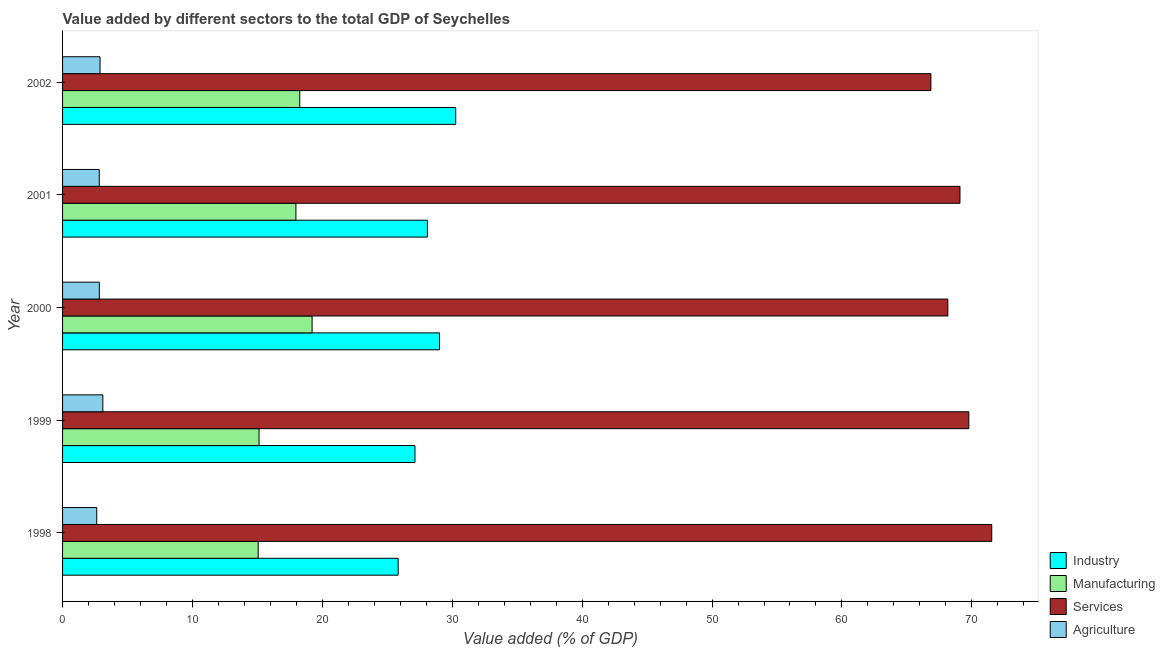How many groups of bars are there?
Your answer should be compact. 5. Are the number of bars per tick equal to the number of legend labels?
Your answer should be very brief. Yes. How many bars are there on the 2nd tick from the top?
Your response must be concise. 4. In how many cases, is the number of bars for a given year not equal to the number of legend labels?
Your answer should be very brief. 0. What is the value added by manufacturing sector in 2002?
Your answer should be very brief. 18.26. Across all years, what is the maximum value added by agricultural sector?
Provide a succinct answer. 3.1. Across all years, what is the minimum value added by agricultural sector?
Your response must be concise. 2.63. In which year was the value added by services sector maximum?
Keep it short and to the point. 1998. What is the total value added by manufacturing sector in the graph?
Make the answer very short. 85.62. What is the difference between the value added by manufacturing sector in 2000 and that in 2002?
Provide a short and direct response. 0.95. What is the difference between the value added by agricultural sector in 2001 and the value added by manufacturing sector in 1998?
Give a very brief answer. -12.23. What is the average value added by services sector per year?
Give a very brief answer. 69.08. In the year 2001, what is the difference between the value added by services sector and value added by agricultural sector?
Provide a short and direct response. 66.26. Is the value added by agricultural sector in 2000 less than that in 2002?
Keep it short and to the point. Yes. Is the difference between the value added by services sector in 1999 and 2000 greater than the difference between the value added by agricultural sector in 1999 and 2000?
Give a very brief answer. Yes. What is the difference between the highest and the second highest value added by services sector?
Provide a succinct answer. 1.76. What is the difference between the highest and the lowest value added by industrial sector?
Your answer should be very brief. 4.43. In how many years, is the value added by agricultural sector greater than the average value added by agricultural sector taken over all years?
Offer a very short reply. 2. Is the sum of the value added by industrial sector in 1999 and 2000 greater than the maximum value added by agricultural sector across all years?
Your answer should be very brief. Yes. Is it the case that in every year, the sum of the value added by services sector and value added by manufacturing sector is greater than the sum of value added by agricultural sector and value added by industrial sector?
Give a very brief answer. Yes. What does the 1st bar from the top in 1999 represents?
Provide a succinct answer. Agriculture. What does the 4th bar from the bottom in 1999 represents?
Provide a short and direct response. Agriculture. Is it the case that in every year, the sum of the value added by industrial sector and value added by manufacturing sector is greater than the value added by services sector?
Offer a terse response. No. How many bars are there?
Your response must be concise. 20. Are all the bars in the graph horizontal?
Give a very brief answer. Yes. Are the values on the major ticks of X-axis written in scientific E-notation?
Keep it short and to the point. No. Does the graph contain grids?
Your response must be concise. No. Where does the legend appear in the graph?
Make the answer very short. Bottom right. How are the legend labels stacked?
Your response must be concise. Vertical. What is the title of the graph?
Offer a terse response. Value added by different sectors to the total GDP of Seychelles. What is the label or title of the X-axis?
Offer a very short reply. Value added (% of GDP). What is the label or title of the Y-axis?
Keep it short and to the point. Year. What is the Value added (% of GDP) of Industry in 1998?
Give a very brief answer. 25.84. What is the Value added (% of GDP) in Manufacturing in 1998?
Your answer should be compact. 15.06. What is the Value added (% of GDP) in Services in 1998?
Make the answer very short. 71.53. What is the Value added (% of GDP) in Agriculture in 1998?
Provide a succinct answer. 2.63. What is the Value added (% of GDP) in Industry in 1999?
Your response must be concise. 27.13. What is the Value added (% of GDP) in Manufacturing in 1999?
Your answer should be compact. 15.12. What is the Value added (% of GDP) of Services in 1999?
Offer a terse response. 69.77. What is the Value added (% of GDP) of Agriculture in 1999?
Provide a short and direct response. 3.1. What is the Value added (% of GDP) in Industry in 2000?
Offer a terse response. 29.02. What is the Value added (% of GDP) of Manufacturing in 2000?
Ensure brevity in your answer.  19.21. What is the Value added (% of GDP) in Services in 2000?
Give a very brief answer. 68.15. What is the Value added (% of GDP) in Agriculture in 2000?
Give a very brief answer. 2.83. What is the Value added (% of GDP) of Industry in 2001?
Give a very brief answer. 28.09. What is the Value added (% of GDP) in Manufacturing in 2001?
Give a very brief answer. 17.96. What is the Value added (% of GDP) of Services in 2001?
Provide a short and direct response. 69.09. What is the Value added (% of GDP) of Agriculture in 2001?
Provide a succinct answer. 2.83. What is the Value added (% of GDP) in Industry in 2002?
Make the answer very short. 30.27. What is the Value added (% of GDP) of Manufacturing in 2002?
Give a very brief answer. 18.26. What is the Value added (% of GDP) of Services in 2002?
Ensure brevity in your answer.  66.85. What is the Value added (% of GDP) in Agriculture in 2002?
Ensure brevity in your answer.  2.89. Across all years, what is the maximum Value added (% of GDP) in Industry?
Provide a succinct answer. 30.27. Across all years, what is the maximum Value added (% of GDP) of Manufacturing?
Provide a succinct answer. 19.21. Across all years, what is the maximum Value added (% of GDP) of Services?
Offer a very short reply. 71.53. Across all years, what is the maximum Value added (% of GDP) in Agriculture?
Give a very brief answer. 3.1. Across all years, what is the minimum Value added (% of GDP) of Industry?
Offer a terse response. 25.84. Across all years, what is the minimum Value added (% of GDP) in Manufacturing?
Keep it short and to the point. 15.06. Across all years, what is the minimum Value added (% of GDP) in Services?
Ensure brevity in your answer.  66.85. Across all years, what is the minimum Value added (% of GDP) of Agriculture?
Offer a very short reply. 2.63. What is the total Value added (% of GDP) of Industry in the graph?
Your answer should be compact. 140.34. What is the total Value added (% of GDP) in Manufacturing in the graph?
Provide a succinct answer. 85.62. What is the total Value added (% of GDP) of Services in the graph?
Provide a short and direct response. 345.39. What is the total Value added (% of GDP) of Agriculture in the graph?
Provide a short and direct response. 14.27. What is the difference between the Value added (% of GDP) in Industry in 1998 and that in 1999?
Offer a terse response. -1.29. What is the difference between the Value added (% of GDP) in Manufacturing in 1998 and that in 1999?
Give a very brief answer. -0.07. What is the difference between the Value added (% of GDP) of Services in 1998 and that in 1999?
Provide a succinct answer. 1.77. What is the difference between the Value added (% of GDP) of Agriculture in 1998 and that in 1999?
Provide a succinct answer. -0.47. What is the difference between the Value added (% of GDP) of Industry in 1998 and that in 2000?
Keep it short and to the point. -3.18. What is the difference between the Value added (% of GDP) of Manufacturing in 1998 and that in 2000?
Provide a short and direct response. -4.15. What is the difference between the Value added (% of GDP) in Services in 1998 and that in 2000?
Give a very brief answer. 3.38. What is the difference between the Value added (% of GDP) in Agriculture in 1998 and that in 2000?
Provide a succinct answer. -0.2. What is the difference between the Value added (% of GDP) in Industry in 1998 and that in 2001?
Ensure brevity in your answer.  -2.25. What is the difference between the Value added (% of GDP) in Manufacturing in 1998 and that in 2001?
Make the answer very short. -2.91. What is the difference between the Value added (% of GDP) of Services in 1998 and that in 2001?
Keep it short and to the point. 2.45. What is the difference between the Value added (% of GDP) in Agriculture in 1998 and that in 2001?
Make the answer very short. -0.2. What is the difference between the Value added (% of GDP) in Industry in 1998 and that in 2002?
Provide a short and direct response. -4.43. What is the difference between the Value added (% of GDP) in Manufacturing in 1998 and that in 2002?
Ensure brevity in your answer.  -3.2. What is the difference between the Value added (% of GDP) of Services in 1998 and that in 2002?
Offer a very short reply. 4.69. What is the difference between the Value added (% of GDP) in Agriculture in 1998 and that in 2002?
Provide a succinct answer. -0.26. What is the difference between the Value added (% of GDP) in Industry in 1999 and that in 2000?
Give a very brief answer. -1.89. What is the difference between the Value added (% of GDP) in Manufacturing in 1999 and that in 2000?
Your answer should be compact. -4.08. What is the difference between the Value added (% of GDP) in Services in 1999 and that in 2000?
Offer a very short reply. 1.62. What is the difference between the Value added (% of GDP) of Agriculture in 1999 and that in 2000?
Give a very brief answer. 0.27. What is the difference between the Value added (% of GDP) of Industry in 1999 and that in 2001?
Make the answer very short. -0.95. What is the difference between the Value added (% of GDP) in Manufacturing in 1999 and that in 2001?
Your answer should be compact. -2.84. What is the difference between the Value added (% of GDP) in Services in 1999 and that in 2001?
Provide a succinct answer. 0.68. What is the difference between the Value added (% of GDP) of Agriculture in 1999 and that in 2001?
Offer a terse response. 0.27. What is the difference between the Value added (% of GDP) of Industry in 1999 and that in 2002?
Offer a very short reply. -3.14. What is the difference between the Value added (% of GDP) of Manufacturing in 1999 and that in 2002?
Your response must be concise. -3.14. What is the difference between the Value added (% of GDP) of Services in 1999 and that in 2002?
Give a very brief answer. 2.92. What is the difference between the Value added (% of GDP) in Agriculture in 1999 and that in 2002?
Provide a short and direct response. 0.22. What is the difference between the Value added (% of GDP) in Industry in 2000 and that in 2001?
Ensure brevity in your answer.  0.93. What is the difference between the Value added (% of GDP) in Manufacturing in 2000 and that in 2001?
Offer a very short reply. 1.25. What is the difference between the Value added (% of GDP) of Services in 2000 and that in 2001?
Give a very brief answer. -0.94. What is the difference between the Value added (% of GDP) of Agriculture in 2000 and that in 2001?
Give a very brief answer. 0. What is the difference between the Value added (% of GDP) in Industry in 2000 and that in 2002?
Provide a short and direct response. -1.25. What is the difference between the Value added (% of GDP) of Manufacturing in 2000 and that in 2002?
Make the answer very short. 0.95. What is the difference between the Value added (% of GDP) of Services in 2000 and that in 2002?
Your answer should be compact. 1.3. What is the difference between the Value added (% of GDP) of Agriculture in 2000 and that in 2002?
Offer a very short reply. -0.06. What is the difference between the Value added (% of GDP) in Industry in 2001 and that in 2002?
Make the answer very short. -2.18. What is the difference between the Value added (% of GDP) in Manufacturing in 2001 and that in 2002?
Your answer should be compact. -0.3. What is the difference between the Value added (% of GDP) of Services in 2001 and that in 2002?
Your answer should be very brief. 2.24. What is the difference between the Value added (% of GDP) of Agriculture in 2001 and that in 2002?
Give a very brief answer. -0.06. What is the difference between the Value added (% of GDP) in Industry in 1998 and the Value added (% of GDP) in Manufacturing in 1999?
Offer a very short reply. 10.71. What is the difference between the Value added (% of GDP) of Industry in 1998 and the Value added (% of GDP) of Services in 1999?
Make the answer very short. -43.93. What is the difference between the Value added (% of GDP) in Industry in 1998 and the Value added (% of GDP) in Agriculture in 1999?
Offer a very short reply. 22.74. What is the difference between the Value added (% of GDP) of Manufacturing in 1998 and the Value added (% of GDP) of Services in 1999?
Keep it short and to the point. -54.71. What is the difference between the Value added (% of GDP) in Manufacturing in 1998 and the Value added (% of GDP) in Agriculture in 1999?
Offer a terse response. 11.96. What is the difference between the Value added (% of GDP) in Services in 1998 and the Value added (% of GDP) in Agriculture in 1999?
Offer a terse response. 68.43. What is the difference between the Value added (% of GDP) of Industry in 1998 and the Value added (% of GDP) of Manufacturing in 2000?
Provide a short and direct response. 6.63. What is the difference between the Value added (% of GDP) of Industry in 1998 and the Value added (% of GDP) of Services in 2000?
Offer a terse response. -42.32. What is the difference between the Value added (% of GDP) of Industry in 1998 and the Value added (% of GDP) of Agriculture in 2000?
Offer a very short reply. 23.01. What is the difference between the Value added (% of GDP) in Manufacturing in 1998 and the Value added (% of GDP) in Services in 2000?
Give a very brief answer. -53.09. What is the difference between the Value added (% of GDP) of Manufacturing in 1998 and the Value added (% of GDP) of Agriculture in 2000?
Offer a very short reply. 12.23. What is the difference between the Value added (% of GDP) of Services in 1998 and the Value added (% of GDP) of Agriculture in 2000?
Your response must be concise. 68.7. What is the difference between the Value added (% of GDP) in Industry in 1998 and the Value added (% of GDP) in Manufacturing in 2001?
Provide a succinct answer. 7.87. What is the difference between the Value added (% of GDP) of Industry in 1998 and the Value added (% of GDP) of Services in 2001?
Your answer should be compact. -43.25. What is the difference between the Value added (% of GDP) in Industry in 1998 and the Value added (% of GDP) in Agriculture in 2001?
Give a very brief answer. 23.01. What is the difference between the Value added (% of GDP) in Manufacturing in 1998 and the Value added (% of GDP) in Services in 2001?
Offer a very short reply. -54.03. What is the difference between the Value added (% of GDP) of Manufacturing in 1998 and the Value added (% of GDP) of Agriculture in 2001?
Provide a succinct answer. 12.23. What is the difference between the Value added (% of GDP) of Services in 1998 and the Value added (% of GDP) of Agriculture in 2001?
Your answer should be compact. 68.71. What is the difference between the Value added (% of GDP) in Industry in 1998 and the Value added (% of GDP) in Manufacturing in 2002?
Your response must be concise. 7.58. What is the difference between the Value added (% of GDP) of Industry in 1998 and the Value added (% of GDP) of Services in 2002?
Make the answer very short. -41.01. What is the difference between the Value added (% of GDP) of Industry in 1998 and the Value added (% of GDP) of Agriculture in 2002?
Your response must be concise. 22.95. What is the difference between the Value added (% of GDP) in Manufacturing in 1998 and the Value added (% of GDP) in Services in 2002?
Your response must be concise. -51.79. What is the difference between the Value added (% of GDP) in Manufacturing in 1998 and the Value added (% of GDP) in Agriculture in 2002?
Provide a succinct answer. 12.17. What is the difference between the Value added (% of GDP) in Services in 1998 and the Value added (% of GDP) in Agriculture in 2002?
Give a very brief answer. 68.65. What is the difference between the Value added (% of GDP) of Industry in 1999 and the Value added (% of GDP) of Manufacturing in 2000?
Make the answer very short. 7.92. What is the difference between the Value added (% of GDP) in Industry in 1999 and the Value added (% of GDP) in Services in 2000?
Make the answer very short. -41.02. What is the difference between the Value added (% of GDP) of Industry in 1999 and the Value added (% of GDP) of Agriculture in 2000?
Your response must be concise. 24.3. What is the difference between the Value added (% of GDP) of Manufacturing in 1999 and the Value added (% of GDP) of Services in 2000?
Provide a short and direct response. -53.03. What is the difference between the Value added (% of GDP) of Manufacturing in 1999 and the Value added (% of GDP) of Agriculture in 2000?
Provide a succinct answer. 12.3. What is the difference between the Value added (% of GDP) of Services in 1999 and the Value added (% of GDP) of Agriculture in 2000?
Your response must be concise. 66.94. What is the difference between the Value added (% of GDP) of Industry in 1999 and the Value added (% of GDP) of Manufacturing in 2001?
Provide a succinct answer. 9.17. What is the difference between the Value added (% of GDP) of Industry in 1999 and the Value added (% of GDP) of Services in 2001?
Your answer should be compact. -41.96. What is the difference between the Value added (% of GDP) in Industry in 1999 and the Value added (% of GDP) in Agriculture in 2001?
Keep it short and to the point. 24.31. What is the difference between the Value added (% of GDP) in Manufacturing in 1999 and the Value added (% of GDP) in Services in 2001?
Provide a short and direct response. -53.96. What is the difference between the Value added (% of GDP) of Manufacturing in 1999 and the Value added (% of GDP) of Agriculture in 2001?
Your answer should be very brief. 12.3. What is the difference between the Value added (% of GDP) in Services in 1999 and the Value added (% of GDP) in Agriculture in 2001?
Your answer should be very brief. 66.94. What is the difference between the Value added (% of GDP) of Industry in 1999 and the Value added (% of GDP) of Manufacturing in 2002?
Provide a short and direct response. 8.87. What is the difference between the Value added (% of GDP) in Industry in 1999 and the Value added (% of GDP) in Services in 2002?
Your response must be concise. -39.72. What is the difference between the Value added (% of GDP) in Industry in 1999 and the Value added (% of GDP) in Agriculture in 2002?
Your answer should be very brief. 24.25. What is the difference between the Value added (% of GDP) in Manufacturing in 1999 and the Value added (% of GDP) in Services in 2002?
Ensure brevity in your answer.  -51.72. What is the difference between the Value added (% of GDP) of Manufacturing in 1999 and the Value added (% of GDP) of Agriculture in 2002?
Offer a very short reply. 12.24. What is the difference between the Value added (% of GDP) of Services in 1999 and the Value added (% of GDP) of Agriculture in 2002?
Provide a succinct answer. 66.88. What is the difference between the Value added (% of GDP) in Industry in 2000 and the Value added (% of GDP) in Manufacturing in 2001?
Your response must be concise. 11.05. What is the difference between the Value added (% of GDP) in Industry in 2000 and the Value added (% of GDP) in Services in 2001?
Offer a terse response. -40.07. What is the difference between the Value added (% of GDP) in Industry in 2000 and the Value added (% of GDP) in Agriculture in 2001?
Keep it short and to the point. 26.19. What is the difference between the Value added (% of GDP) of Manufacturing in 2000 and the Value added (% of GDP) of Services in 2001?
Offer a very short reply. -49.88. What is the difference between the Value added (% of GDP) in Manufacturing in 2000 and the Value added (% of GDP) in Agriculture in 2001?
Give a very brief answer. 16.38. What is the difference between the Value added (% of GDP) in Services in 2000 and the Value added (% of GDP) in Agriculture in 2001?
Give a very brief answer. 65.33. What is the difference between the Value added (% of GDP) of Industry in 2000 and the Value added (% of GDP) of Manufacturing in 2002?
Your answer should be compact. 10.76. What is the difference between the Value added (% of GDP) of Industry in 2000 and the Value added (% of GDP) of Services in 2002?
Your answer should be compact. -37.83. What is the difference between the Value added (% of GDP) of Industry in 2000 and the Value added (% of GDP) of Agriculture in 2002?
Provide a short and direct response. 26.13. What is the difference between the Value added (% of GDP) of Manufacturing in 2000 and the Value added (% of GDP) of Services in 2002?
Keep it short and to the point. -47.64. What is the difference between the Value added (% of GDP) in Manufacturing in 2000 and the Value added (% of GDP) in Agriculture in 2002?
Offer a terse response. 16.32. What is the difference between the Value added (% of GDP) in Services in 2000 and the Value added (% of GDP) in Agriculture in 2002?
Offer a terse response. 65.27. What is the difference between the Value added (% of GDP) in Industry in 2001 and the Value added (% of GDP) in Manufacturing in 2002?
Ensure brevity in your answer.  9.82. What is the difference between the Value added (% of GDP) in Industry in 2001 and the Value added (% of GDP) in Services in 2002?
Make the answer very short. -38.76. What is the difference between the Value added (% of GDP) of Industry in 2001 and the Value added (% of GDP) of Agriculture in 2002?
Offer a terse response. 25.2. What is the difference between the Value added (% of GDP) of Manufacturing in 2001 and the Value added (% of GDP) of Services in 2002?
Make the answer very short. -48.88. What is the difference between the Value added (% of GDP) of Manufacturing in 2001 and the Value added (% of GDP) of Agriculture in 2002?
Make the answer very short. 15.08. What is the difference between the Value added (% of GDP) of Services in 2001 and the Value added (% of GDP) of Agriculture in 2002?
Offer a very short reply. 66.2. What is the average Value added (% of GDP) in Industry per year?
Ensure brevity in your answer.  28.07. What is the average Value added (% of GDP) of Manufacturing per year?
Offer a terse response. 17.12. What is the average Value added (% of GDP) in Services per year?
Give a very brief answer. 69.08. What is the average Value added (% of GDP) of Agriculture per year?
Provide a succinct answer. 2.85. In the year 1998, what is the difference between the Value added (% of GDP) of Industry and Value added (% of GDP) of Manufacturing?
Provide a succinct answer. 10.78. In the year 1998, what is the difference between the Value added (% of GDP) in Industry and Value added (% of GDP) in Services?
Offer a very short reply. -45.7. In the year 1998, what is the difference between the Value added (% of GDP) of Industry and Value added (% of GDP) of Agriculture?
Offer a terse response. 23.21. In the year 1998, what is the difference between the Value added (% of GDP) of Manufacturing and Value added (% of GDP) of Services?
Offer a very short reply. -56.47. In the year 1998, what is the difference between the Value added (% of GDP) of Manufacturing and Value added (% of GDP) of Agriculture?
Your answer should be compact. 12.43. In the year 1998, what is the difference between the Value added (% of GDP) of Services and Value added (% of GDP) of Agriculture?
Provide a short and direct response. 68.9. In the year 1999, what is the difference between the Value added (% of GDP) of Industry and Value added (% of GDP) of Manufacturing?
Offer a terse response. 12.01. In the year 1999, what is the difference between the Value added (% of GDP) of Industry and Value added (% of GDP) of Services?
Your answer should be compact. -42.64. In the year 1999, what is the difference between the Value added (% of GDP) of Industry and Value added (% of GDP) of Agriculture?
Make the answer very short. 24.03. In the year 1999, what is the difference between the Value added (% of GDP) of Manufacturing and Value added (% of GDP) of Services?
Your answer should be very brief. -54.64. In the year 1999, what is the difference between the Value added (% of GDP) of Manufacturing and Value added (% of GDP) of Agriculture?
Offer a terse response. 12.02. In the year 1999, what is the difference between the Value added (% of GDP) in Services and Value added (% of GDP) in Agriculture?
Make the answer very short. 66.67. In the year 2000, what is the difference between the Value added (% of GDP) in Industry and Value added (% of GDP) in Manufacturing?
Your response must be concise. 9.81. In the year 2000, what is the difference between the Value added (% of GDP) in Industry and Value added (% of GDP) in Services?
Your answer should be compact. -39.13. In the year 2000, what is the difference between the Value added (% of GDP) in Industry and Value added (% of GDP) in Agriculture?
Keep it short and to the point. 26.19. In the year 2000, what is the difference between the Value added (% of GDP) in Manufacturing and Value added (% of GDP) in Services?
Your answer should be compact. -48.94. In the year 2000, what is the difference between the Value added (% of GDP) of Manufacturing and Value added (% of GDP) of Agriculture?
Provide a short and direct response. 16.38. In the year 2000, what is the difference between the Value added (% of GDP) of Services and Value added (% of GDP) of Agriculture?
Offer a terse response. 65.32. In the year 2001, what is the difference between the Value added (% of GDP) in Industry and Value added (% of GDP) in Manufacturing?
Provide a short and direct response. 10.12. In the year 2001, what is the difference between the Value added (% of GDP) in Industry and Value added (% of GDP) in Services?
Offer a terse response. -41. In the year 2001, what is the difference between the Value added (% of GDP) in Industry and Value added (% of GDP) in Agriculture?
Provide a succinct answer. 25.26. In the year 2001, what is the difference between the Value added (% of GDP) in Manufacturing and Value added (% of GDP) in Services?
Provide a short and direct response. -51.12. In the year 2001, what is the difference between the Value added (% of GDP) of Manufacturing and Value added (% of GDP) of Agriculture?
Offer a very short reply. 15.14. In the year 2001, what is the difference between the Value added (% of GDP) of Services and Value added (% of GDP) of Agriculture?
Ensure brevity in your answer.  66.26. In the year 2002, what is the difference between the Value added (% of GDP) of Industry and Value added (% of GDP) of Manufacturing?
Provide a short and direct response. 12.01. In the year 2002, what is the difference between the Value added (% of GDP) of Industry and Value added (% of GDP) of Services?
Your answer should be very brief. -36.58. In the year 2002, what is the difference between the Value added (% of GDP) of Industry and Value added (% of GDP) of Agriculture?
Offer a very short reply. 27.38. In the year 2002, what is the difference between the Value added (% of GDP) of Manufacturing and Value added (% of GDP) of Services?
Make the answer very short. -48.59. In the year 2002, what is the difference between the Value added (% of GDP) in Manufacturing and Value added (% of GDP) in Agriculture?
Provide a succinct answer. 15.38. In the year 2002, what is the difference between the Value added (% of GDP) in Services and Value added (% of GDP) in Agriculture?
Provide a short and direct response. 63.96. What is the ratio of the Value added (% of GDP) of Industry in 1998 to that in 1999?
Your answer should be compact. 0.95. What is the ratio of the Value added (% of GDP) of Services in 1998 to that in 1999?
Provide a succinct answer. 1.03. What is the ratio of the Value added (% of GDP) in Agriculture in 1998 to that in 1999?
Provide a succinct answer. 0.85. What is the ratio of the Value added (% of GDP) of Industry in 1998 to that in 2000?
Your answer should be compact. 0.89. What is the ratio of the Value added (% of GDP) in Manufacturing in 1998 to that in 2000?
Give a very brief answer. 0.78. What is the ratio of the Value added (% of GDP) of Services in 1998 to that in 2000?
Your answer should be compact. 1.05. What is the ratio of the Value added (% of GDP) in Agriculture in 1998 to that in 2000?
Give a very brief answer. 0.93. What is the ratio of the Value added (% of GDP) in Industry in 1998 to that in 2001?
Provide a short and direct response. 0.92. What is the ratio of the Value added (% of GDP) of Manufacturing in 1998 to that in 2001?
Offer a very short reply. 0.84. What is the ratio of the Value added (% of GDP) in Services in 1998 to that in 2001?
Ensure brevity in your answer.  1.04. What is the ratio of the Value added (% of GDP) of Agriculture in 1998 to that in 2001?
Your response must be concise. 0.93. What is the ratio of the Value added (% of GDP) in Industry in 1998 to that in 2002?
Your answer should be compact. 0.85. What is the ratio of the Value added (% of GDP) of Manufacturing in 1998 to that in 2002?
Keep it short and to the point. 0.82. What is the ratio of the Value added (% of GDP) of Services in 1998 to that in 2002?
Give a very brief answer. 1.07. What is the ratio of the Value added (% of GDP) in Agriculture in 1998 to that in 2002?
Offer a very short reply. 0.91. What is the ratio of the Value added (% of GDP) of Industry in 1999 to that in 2000?
Your answer should be very brief. 0.94. What is the ratio of the Value added (% of GDP) in Manufacturing in 1999 to that in 2000?
Provide a short and direct response. 0.79. What is the ratio of the Value added (% of GDP) of Services in 1999 to that in 2000?
Provide a short and direct response. 1.02. What is the ratio of the Value added (% of GDP) of Agriculture in 1999 to that in 2000?
Offer a very short reply. 1.1. What is the ratio of the Value added (% of GDP) of Manufacturing in 1999 to that in 2001?
Provide a short and direct response. 0.84. What is the ratio of the Value added (% of GDP) in Services in 1999 to that in 2001?
Your response must be concise. 1.01. What is the ratio of the Value added (% of GDP) of Agriculture in 1999 to that in 2001?
Make the answer very short. 1.1. What is the ratio of the Value added (% of GDP) of Industry in 1999 to that in 2002?
Provide a short and direct response. 0.9. What is the ratio of the Value added (% of GDP) in Manufacturing in 1999 to that in 2002?
Offer a very short reply. 0.83. What is the ratio of the Value added (% of GDP) of Services in 1999 to that in 2002?
Offer a very short reply. 1.04. What is the ratio of the Value added (% of GDP) in Agriculture in 1999 to that in 2002?
Your answer should be very brief. 1.07. What is the ratio of the Value added (% of GDP) in Industry in 2000 to that in 2001?
Your response must be concise. 1.03. What is the ratio of the Value added (% of GDP) of Manufacturing in 2000 to that in 2001?
Give a very brief answer. 1.07. What is the ratio of the Value added (% of GDP) of Services in 2000 to that in 2001?
Offer a terse response. 0.99. What is the ratio of the Value added (% of GDP) of Agriculture in 2000 to that in 2001?
Offer a very short reply. 1. What is the ratio of the Value added (% of GDP) of Industry in 2000 to that in 2002?
Ensure brevity in your answer.  0.96. What is the ratio of the Value added (% of GDP) in Manufacturing in 2000 to that in 2002?
Provide a short and direct response. 1.05. What is the ratio of the Value added (% of GDP) of Services in 2000 to that in 2002?
Your answer should be very brief. 1.02. What is the ratio of the Value added (% of GDP) in Agriculture in 2000 to that in 2002?
Offer a terse response. 0.98. What is the ratio of the Value added (% of GDP) in Industry in 2001 to that in 2002?
Offer a very short reply. 0.93. What is the ratio of the Value added (% of GDP) in Manufacturing in 2001 to that in 2002?
Provide a succinct answer. 0.98. What is the ratio of the Value added (% of GDP) of Services in 2001 to that in 2002?
Ensure brevity in your answer.  1.03. What is the ratio of the Value added (% of GDP) in Agriculture in 2001 to that in 2002?
Your response must be concise. 0.98. What is the difference between the highest and the second highest Value added (% of GDP) in Industry?
Your answer should be compact. 1.25. What is the difference between the highest and the second highest Value added (% of GDP) in Manufacturing?
Keep it short and to the point. 0.95. What is the difference between the highest and the second highest Value added (% of GDP) in Services?
Offer a very short reply. 1.77. What is the difference between the highest and the second highest Value added (% of GDP) of Agriculture?
Your response must be concise. 0.22. What is the difference between the highest and the lowest Value added (% of GDP) in Industry?
Give a very brief answer. 4.43. What is the difference between the highest and the lowest Value added (% of GDP) of Manufacturing?
Provide a short and direct response. 4.15. What is the difference between the highest and the lowest Value added (% of GDP) of Services?
Provide a succinct answer. 4.69. What is the difference between the highest and the lowest Value added (% of GDP) in Agriculture?
Your response must be concise. 0.47. 